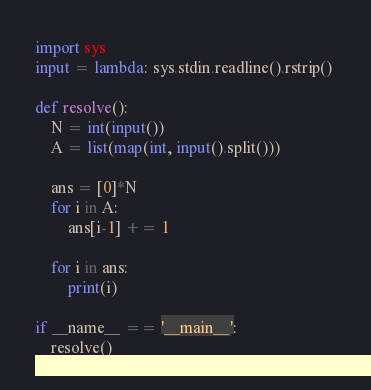<code> <loc_0><loc_0><loc_500><loc_500><_Python_>import sys
input = lambda: sys.stdin.readline().rstrip() 

def resolve():
    N = int(input())
    A = list(map(int, input().split()))

    ans = [0]*N
    for i in A:
        ans[i-1] += 1

    for i in ans:
        print(i)

if __name__ == '__main__':
    resolve()
</code> 